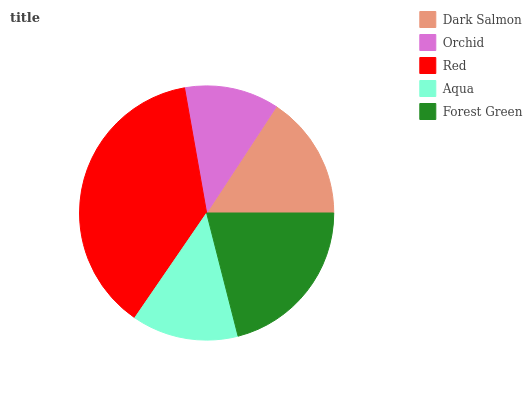Is Orchid the minimum?
Answer yes or no. Yes. Is Red the maximum?
Answer yes or no. Yes. Is Red the minimum?
Answer yes or no. No. Is Orchid the maximum?
Answer yes or no. No. Is Red greater than Orchid?
Answer yes or no. Yes. Is Orchid less than Red?
Answer yes or no. Yes. Is Orchid greater than Red?
Answer yes or no. No. Is Red less than Orchid?
Answer yes or no. No. Is Dark Salmon the high median?
Answer yes or no. Yes. Is Dark Salmon the low median?
Answer yes or no. Yes. Is Orchid the high median?
Answer yes or no. No. Is Aqua the low median?
Answer yes or no. No. 